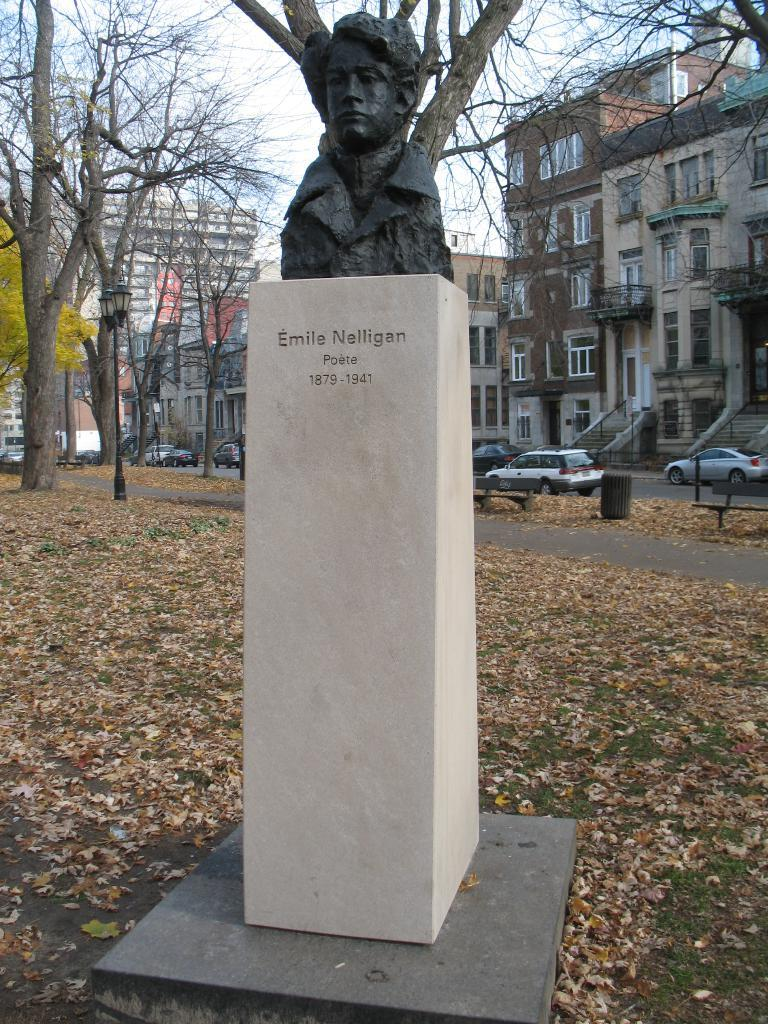What type of structures can be seen in the image? There are buildings in the image. What features do the buildings have? The buildings have windows. What type of vegetation is present in the image? There are trees in the image. What architectural feature can be seen in the image? There are stairs in the image. What type of barrier is present in the image? There is fencing in the image. What type of artwork is present in the image? There is a statue in the image. What type of transportation is present in the image? There are vehicles in the image. What type of natural debris can be seen on the road? There are brown color leaves on the road. What part of the natural environment is visible in the image? The sky is visible in the image. What type of cord is being used to control the action of the rifle in the image? There is no cord or rifle present in the image. 